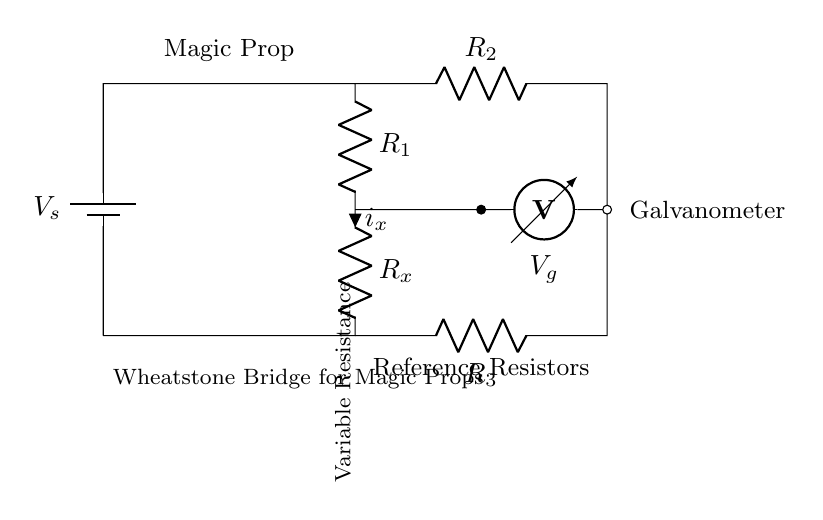What type of circuit is depicted? This circuit is a Wheatstone bridge, identifiable by its configuration of resistors arranged in a diamond shape and connected to a voltage source.
Answer: Wheatstone bridge What are the values of the reference resistors? The values of the reference resistors are indicated by R2 and R3 in the diagram, but actual numerical values are not provided.
Answer: R2 and R3 What is the name of the component measuring voltage? The component measuring voltage is a galvanometer, depicted in the circuit as a symbol for a voltmeter connected across the bridge.
Answer: Galvanometer How many resistors are in the circuit? The circuit contains four resistors: R1, R2, R3, and Rx, making a total of four distinct resistive elements.
Answer: Four What is the purpose of R_x? R_x serves as the variable resistance, allowing slight changes in resistance to be detected, which is essential in applications such as magic props.
Answer: Variable resistance If R1 equals R2, what can be said about V_g? If R1 equals R2, it indicates that the bridge is balanced, resulting in V_g being zero, meaning no current flows through the galvanometer.
Answer: Zero What role does the battery play in this circuit? The battery provides the necessary voltage supply to the Wheatstone bridge configuration, enabling current to flow and allowing the measurement of potential differences.
Answer: Voltage supply 